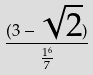Convert formula to latex. <formula><loc_0><loc_0><loc_500><loc_500>\frac { ( 3 - \sqrt { 2 } ) } { \frac { 1 ^ { 6 } } { 7 } }</formula> 